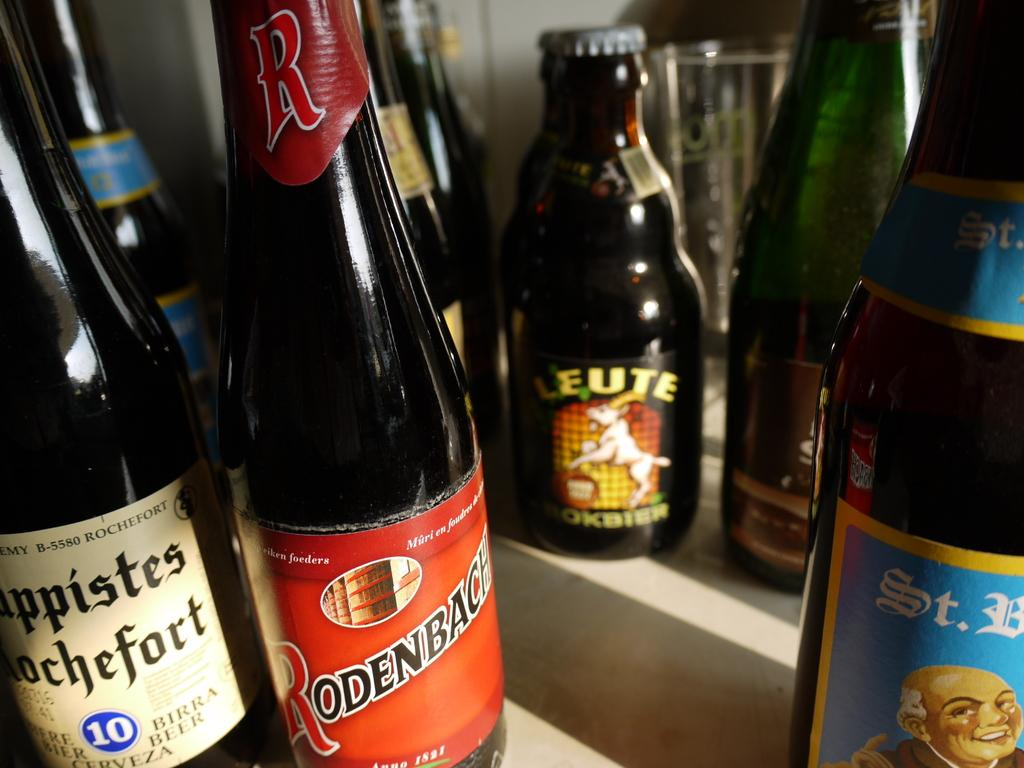<image>
Render a clear and concise summary of the photo. Black bottles with one that has a red label saying Rodenback. 